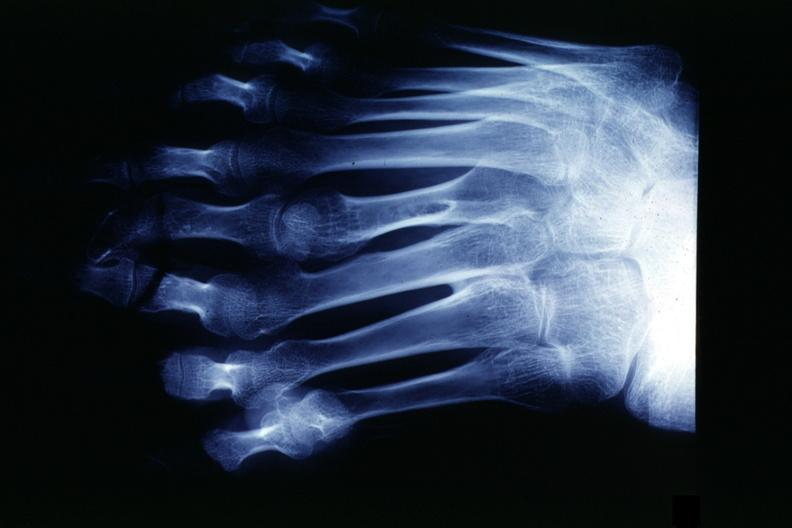how many digits does this image show x-ray strange foot with?
Answer the question using a single word or phrase. 8 